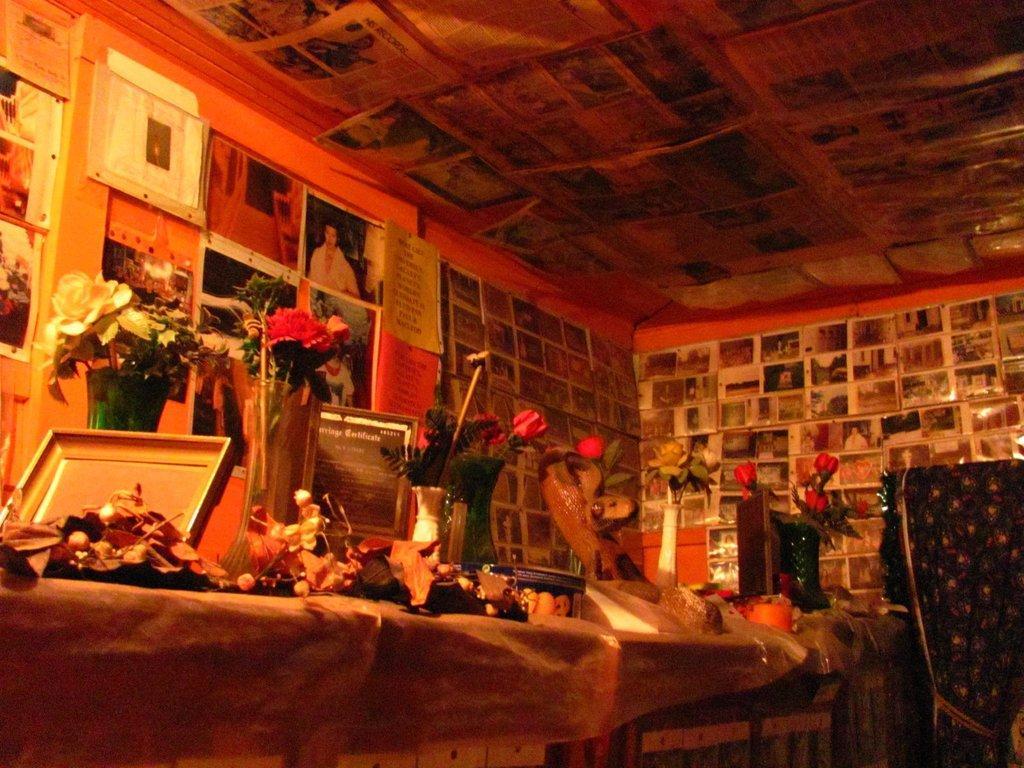Please provide a concise description of this image. In this picture, we see the tables which are covered with the brown color sheets. We see many flower vases, a box and some other objects are placed on the table. Behind that, we see a wall on which many photo frames and posters are pasted. On the right side, we see a curtain in black color. At the top, we see the roof of the building and we see the posts are posted on the roof. 